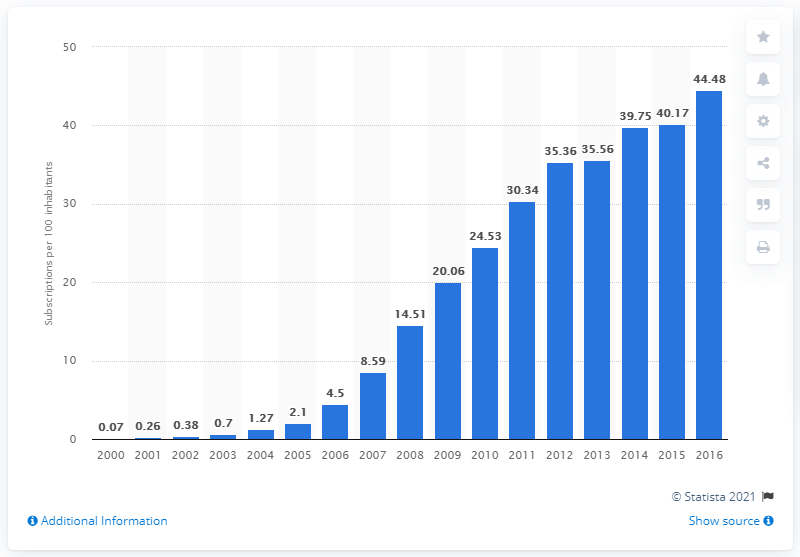Specify some key components in this picture. In Chad, between 2000 and 2016, there were an average of 44.48 mobile subscriptions for every 100 people. 